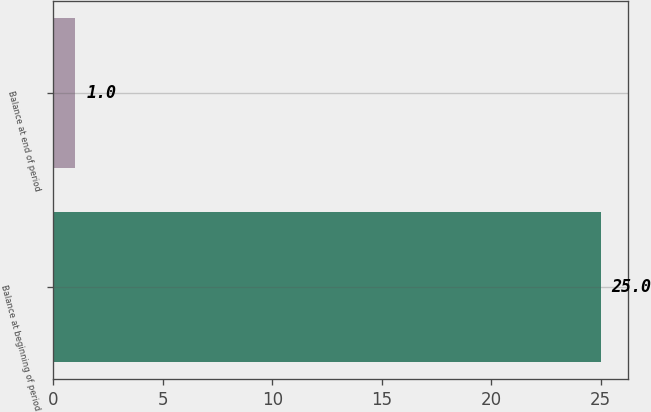Convert chart. <chart><loc_0><loc_0><loc_500><loc_500><bar_chart><fcel>Balance at beginning of period<fcel>Balance at end of period<nl><fcel>25<fcel>1<nl></chart> 